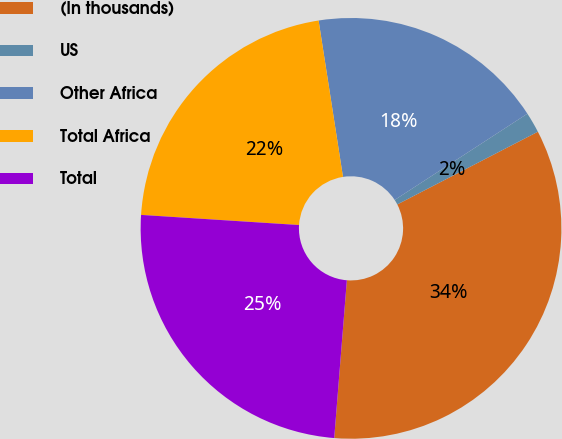Convert chart to OTSL. <chart><loc_0><loc_0><loc_500><loc_500><pie_chart><fcel>(In thousands)<fcel>US<fcel>Other Africa<fcel>Total Africa<fcel>Total<nl><fcel>33.87%<fcel>1.58%<fcel>18.29%<fcel>21.52%<fcel>24.75%<nl></chart> 